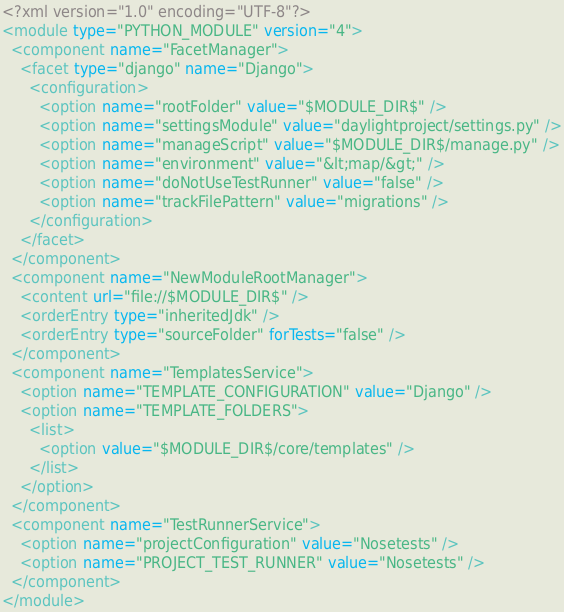<code> <loc_0><loc_0><loc_500><loc_500><_XML_><?xml version="1.0" encoding="UTF-8"?>
<module type="PYTHON_MODULE" version="4">
  <component name="FacetManager">
    <facet type="django" name="Django">
      <configuration>
        <option name="rootFolder" value="$MODULE_DIR$" />
        <option name="settingsModule" value="daylightproject/settings.py" />
        <option name="manageScript" value="$MODULE_DIR$/manage.py" />
        <option name="environment" value="&lt;map/&gt;" />
        <option name="doNotUseTestRunner" value="false" />
        <option name="trackFilePattern" value="migrations" />
      </configuration>
    </facet>
  </component>
  <component name="NewModuleRootManager">
    <content url="file://$MODULE_DIR$" />
    <orderEntry type="inheritedJdk" />
    <orderEntry type="sourceFolder" forTests="false" />
  </component>
  <component name="TemplatesService">
    <option name="TEMPLATE_CONFIGURATION" value="Django" />
    <option name="TEMPLATE_FOLDERS">
      <list>
        <option value="$MODULE_DIR$/core/templates" />
      </list>
    </option>
  </component>
  <component name="TestRunnerService">
    <option name="projectConfiguration" value="Nosetests" />
    <option name="PROJECT_TEST_RUNNER" value="Nosetests" />
  </component>
</module></code> 